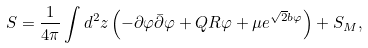Convert formula to latex. <formula><loc_0><loc_0><loc_500><loc_500>S = \frac { 1 } { 4 \pi } \int d ^ { 2 } z \left ( - \partial \varphi \bar { \partial } \varphi + Q R \varphi + \mu e ^ { \sqrt { 2 } b \varphi } \right ) + S _ { M } ,</formula> 